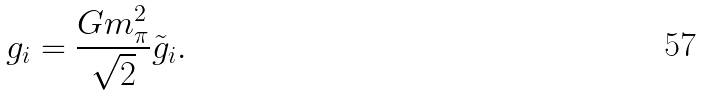<formula> <loc_0><loc_0><loc_500><loc_500>g _ { i } = \frac { G m _ { \pi } ^ { 2 } } { \sqrt { 2 } } \tilde { g } _ { i } .</formula> 